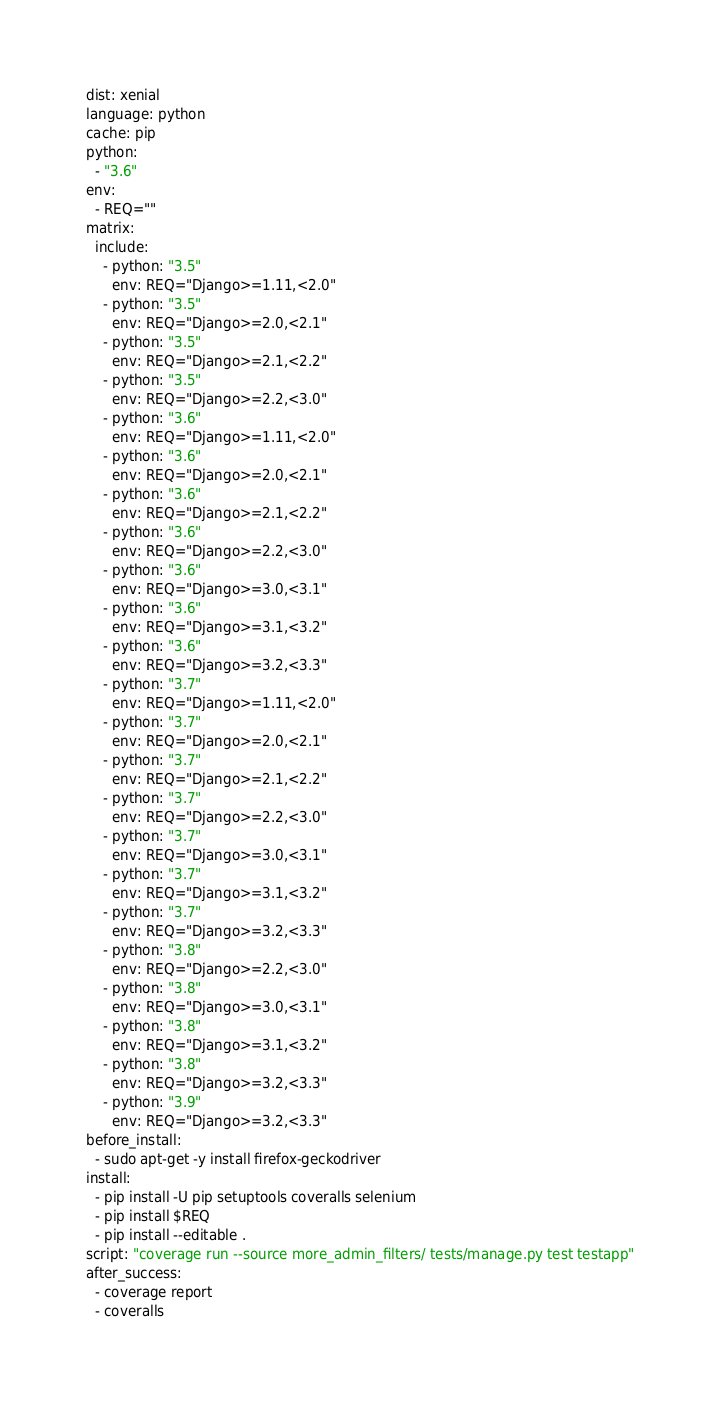<code> <loc_0><loc_0><loc_500><loc_500><_YAML_>dist: xenial
language: python
cache: pip
python:
  - "3.6"
env:
  - REQ=""
matrix:
  include:
    - python: "3.5"
      env: REQ="Django>=1.11,<2.0"
    - python: "3.5"
      env: REQ="Django>=2.0,<2.1"
    - python: "3.5"
      env: REQ="Django>=2.1,<2.2"
    - python: "3.5"
      env: REQ="Django>=2.2,<3.0"
    - python: "3.6"
      env: REQ="Django>=1.11,<2.0"
    - python: "3.6"
      env: REQ="Django>=2.0,<2.1"
    - python: "3.6"
      env: REQ="Django>=2.1,<2.2"
    - python: "3.6"
      env: REQ="Django>=2.2,<3.0"
    - python: "3.6"
      env: REQ="Django>=3.0,<3.1"
    - python: "3.6"
      env: REQ="Django>=3.1,<3.2"
    - python: "3.6"
      env: REQ="Django>=3.2,<3.3"
    - python: "3.7"
      env: REQ="Django>=1.11,<2.0"
    - python: "3.7"
      env: REQ="Django>=2.0,<2.1"
    - python: "3.7"
      env: REQ="Django>=2.1,<2.2"
    - python: "3.7"
      env: REQ="Django>=2.2,<3.0"
    - python: "3.7"
      env: REQ="Django>=3.0,<3.1"
    - python: "3.7"
      env: REQ="Django>=3.1,<3.2"
    - python: "3.7"
      env: REQ="Django>=3.2,<3.3"
    - python: "3.8"
      env: REQ="Django>=2.2,<3.0"
    - python: "3.8"
      env: REQ="Django>=3.0,<3.1"
    - python: "3.8"
      env: REQ="Django>=3.1,<3.2"
    - python: "3.8"
      env: REQ="Django>=3.2,<3.3"
    - python: "3.9"
      env: REQ="Django>=3.2,<3.3"
before_install:
  - sudo apt-get -y install firefox-geckodriver
install:
  - pip install -U pip setuptools coveralls selenium
  - pip install $REQ
  - pip install --editable .
script: "coverage run --source more_admin_filters/ tests/manage.py test testapp"
after_success:
  - coverage report
  - coveralls
</code> 